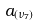Convert formula to latex. <formula><loc_0><loc_0><loc_500><loc_500>a _ { ( \nu _ { 7 } ) }</formula> 